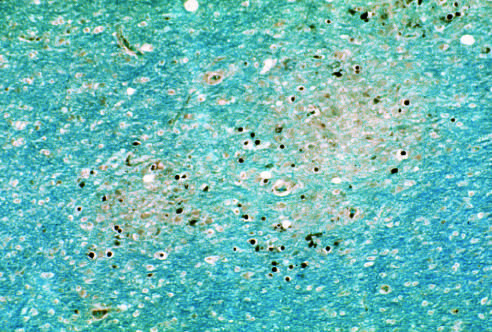what do enlarged oligodendrocyte nuclei stained for viral antigens surround?
Answer the question using a single word or phrase. Areas of early myelin loss 